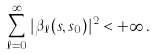<formula> <loc_0><loc_0><loc_500><loc_500>\sum _ { \ell = 0 } ^ { \infty } | \beta _ { \ell } ( s , s _ { 0 } ) | ^ { 2 } < + \infty \, .</formula> 